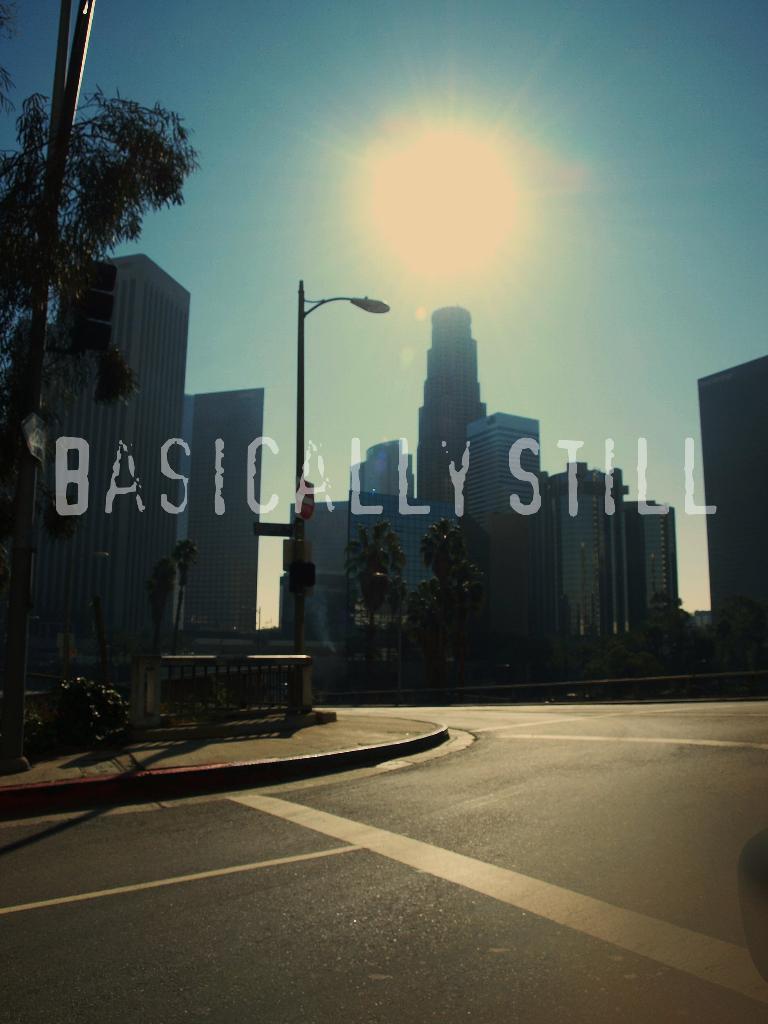Please provide a concise description of this image. This is a picture taken outside a city on the streets. In the foreground of the picture it is road. On the left there are buildings, trees and a street light. In the center of the background there are buildings and trees. Sky is sunny. 